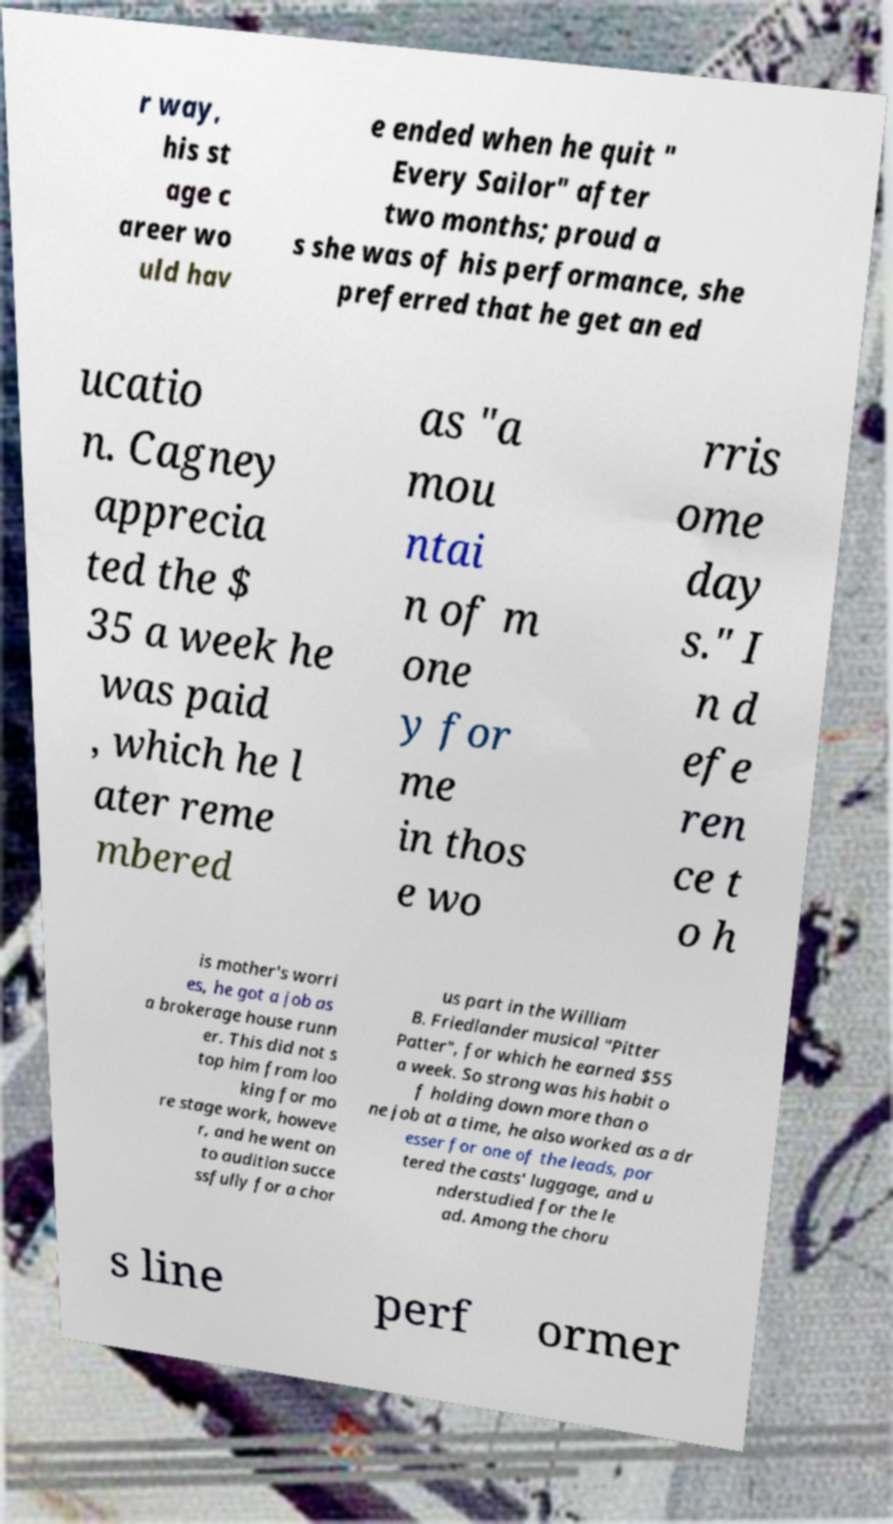Can you read and provide the text displayed in the image?This photo seems to have some interesting text. Can you extract and type it out for me? r way, his st age c areer wo uld hav e ended when he quit " Every Sailor" after two months; proud a s she was of his performance, she preferred that he get an ed ucatio n. Cagney apprecia ted the $ 35 a week he was paid , which he l ater reme mbered as "a mou ntai n of m one y for me in thos e wo rris ome day s." I n d efe ren ce t o h is mother's worri es, he got a job as a brokerage house runn er. This did not s top him from loo king for mo re stage work, howeve r, and he went on to audition succe ssfully for a chor us part in the William B. Friedlander musical "Pitter Patter", for which he earned $55 a week. So strong was his habit o f holding down more than o ne job at a time, he also worked as a dr esser for one of the leads, por tered the casts' luggage, and u nderstudied for the le ad. Among the choru s line perf ormer 